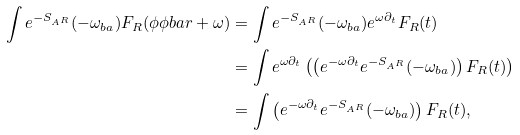Convert formula to latex. <formula><loc_0><loc_0><loc_500><loc_500>\int e ^ { - S _ { A ^ { R } } } ( - \omega _ { b a } ) F _ { R } ( \phi \phi b a r + \omega ) & = \int e ^ { - S _ { A ^ { R } } } ( - \omega _ { b a } ) e ^ { \omega \partial _ { t } } F _ { R } ( t ) \\ & = \int e ^ { \omega \partial _ { t } } \left ( \left ( e ^ { - \omega \partial _ { t } } e ^ { - S _ { A ^ { R } } } ( - \omega _ { b a } ) \right ) F _ { R } ( t ) \right ) \\ & = \int \left ( e ^ { - \omega \partial _ { t } } e ^ { - S _ { A ^ { R } } } ( - \omega _ { b a } ) \right ) F _ { R } ( t ) ,</formula> 